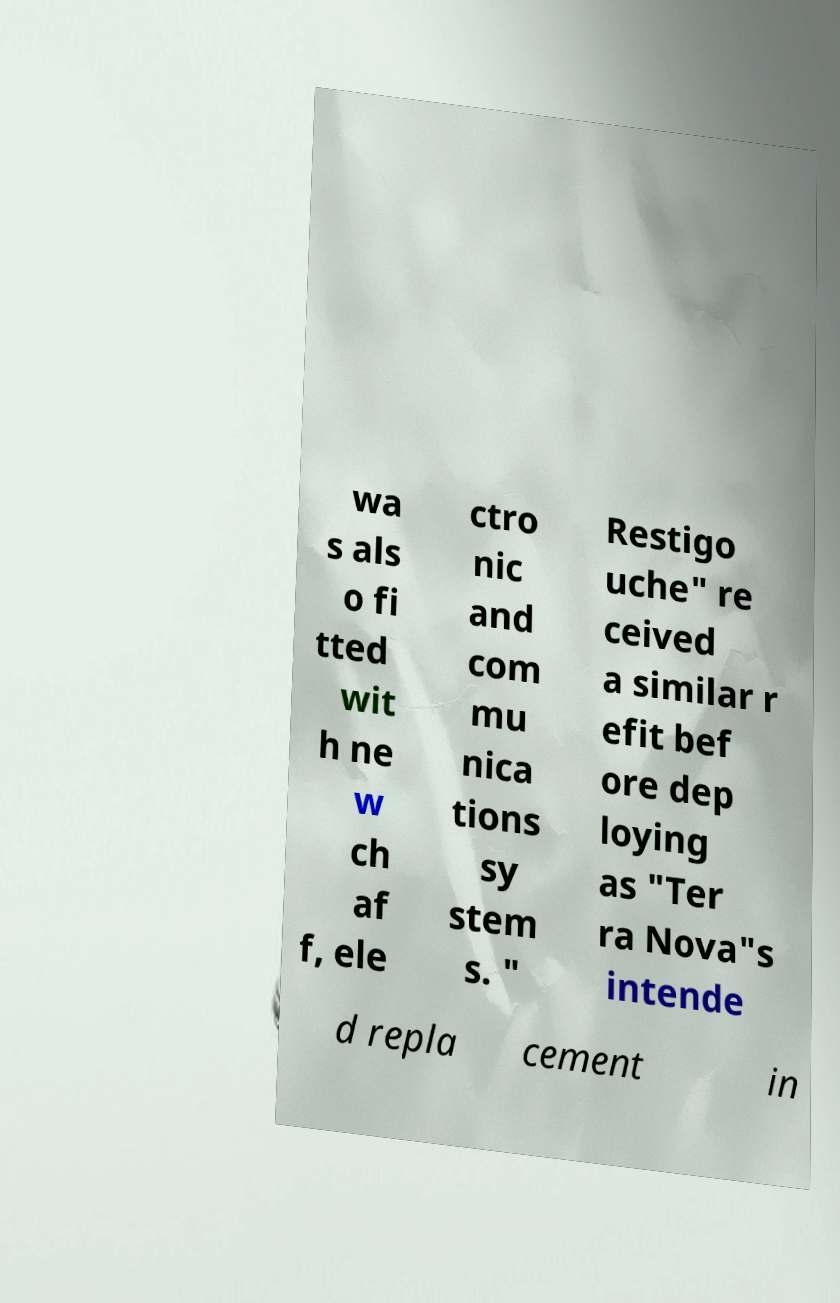Could you assist in decoding the text presented in this image and type it out clearly? wa s als o fi tted wit h ne w ch af f, ele ctro nic and com mu nica tions sy stem s. " Restigo uche" re ceived a similar r efit bef ore dep loying as "Ter ra Nova"s intende d repla cement in 